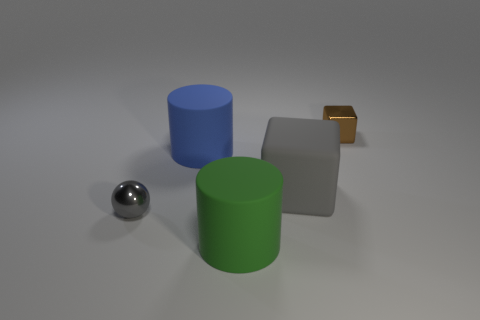There is a matte cylinder that is right of the blue rubber thing; is there a large matte object that is in front of it?
Give a very brief answer. No. Is the number of big blue rubber cylinders on the right side of the big blue thing the same as the number of blue matte cylinders that are behind the brown metallic block?
Provide a succinct answer. Yes. What color is the thing that is made of the same material as the small gray sphere?
Provide a succinct answer. Brown. Is there a brown block that has the same material as the brown object?
Ensure brevity in your answer.  No. How many things are either small green metallic cylinders or blue objects?
Make the answer very short. 1. Is the material of the small cube the same as the big cylinder behind the green object?
Make the answer very short. No. What is the size of the metallic object right of the green matte thing?
Offer a very short reply. Small. Is the number of big gray rubber objects less than the number of blocks?
Your response must be concise. Yes. Are there any rubber things that have the same color as the large rubber block?
Offer a very short reply. No. There is a object that is both behind the tiny sphere and on the left side of the green rubber cylinder; what shape is it?
Offer a very short reply. Cylinder. 